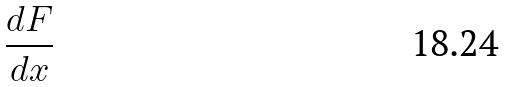Convert formula to latex. <formula><loc_0><loc_0><loc_500><loc_500>\frac { d F } { d x }</formula> 